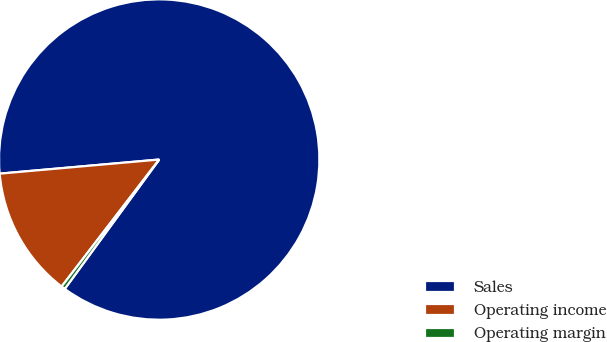<chart> <loc_0><loc_0><loc_500><loc_500><pie_chart><fcel>Sales<fcel>Operating income<fcel>Operating margin<nl><fcel>86.45%<fcel>13.17%<fcel>0.39%<nl></chart> 